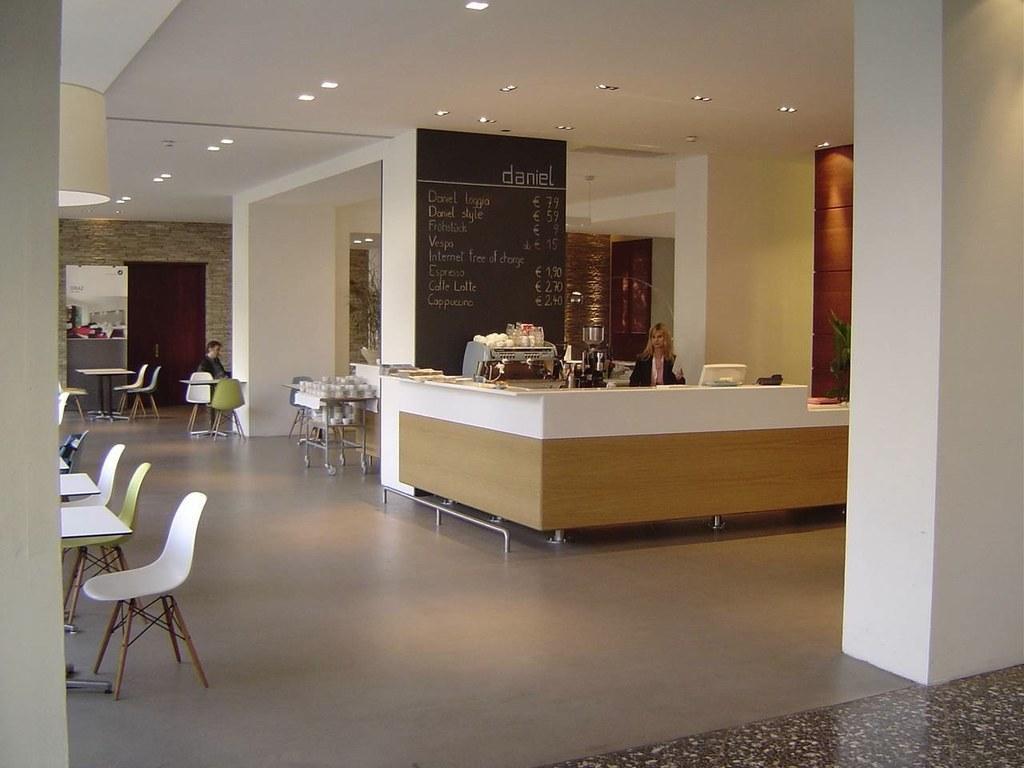Can you describe this image briefly? This is a picture of inside of room, in this picture on the left side there are some chairs and in the center there is a reception table and one woman is sitting and there is one board. On the board there is some text and also we could see some objects, in the background there is wall, tables, chairs and one person is sitting. And also on the tables there are some glasses, doors, wall, lights and at the top there is ceiling and some lights and at the bottom there is floor. 